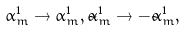Convert formula to latex. <formula><loc_0><loc_0><loc_500><loc_500>\alpha _ { m } ^ { 1 } \to \alpha _ { m } ^ { 1 } , \tilde { \alpha } _ { m } ^ { 1 } \to - \tilde { \alpha } _ { m } ^ { 1 } ,</formula> 